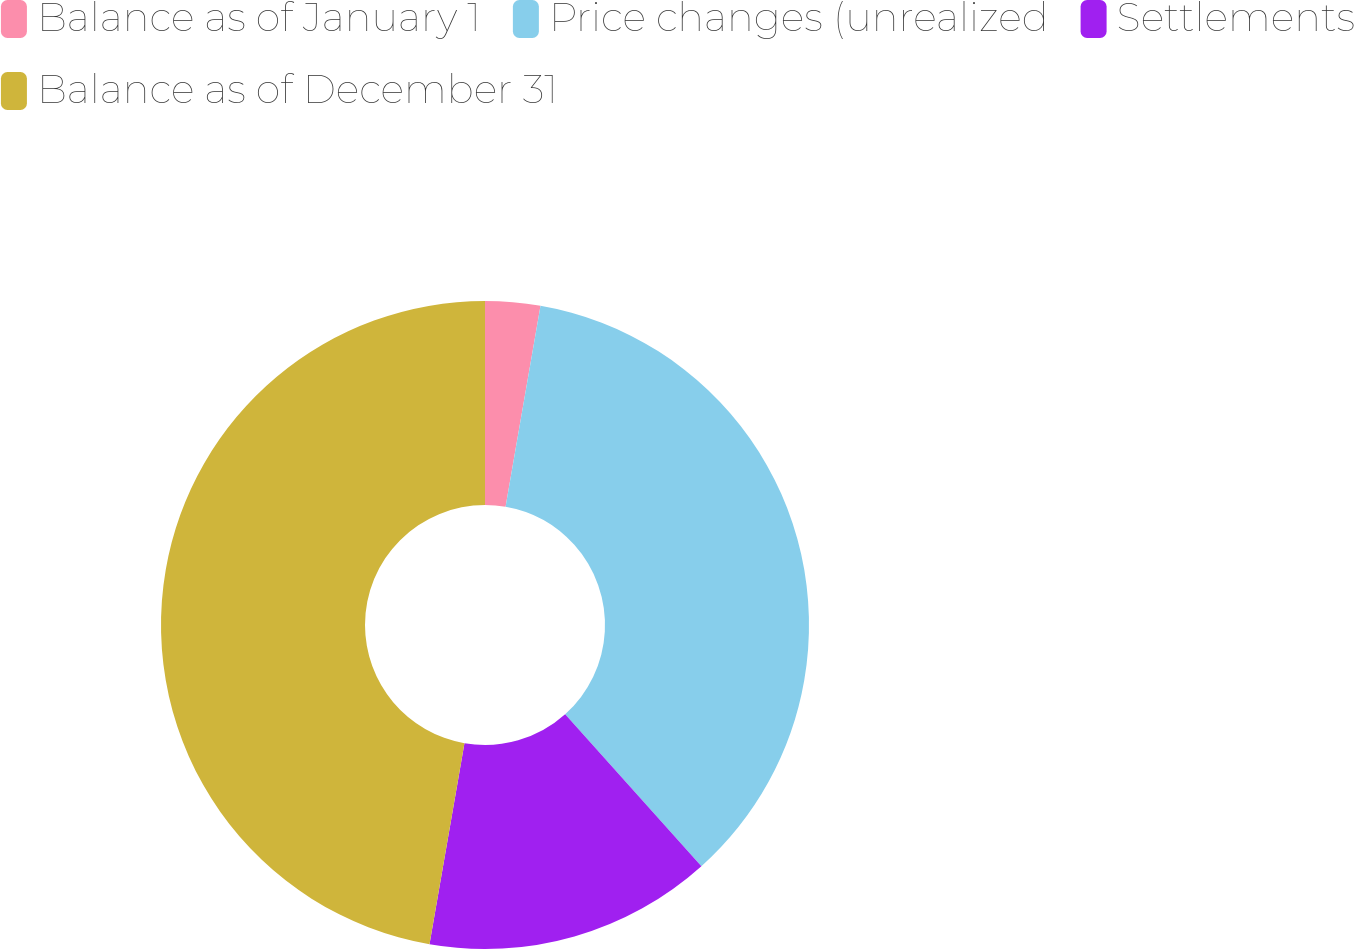Convert chart. <chart><loc_0><loc_0><loc_500><loc_500><pie_chart><fcel>Balance as of January 1<fcel>Price changes (unrealized<fcel>Settlements<fcel>Balance as of December 31<nl><fcel>2.74%<fcel>35.62%<fcel>14.38%<fcel>47.26%<nl></chart> 